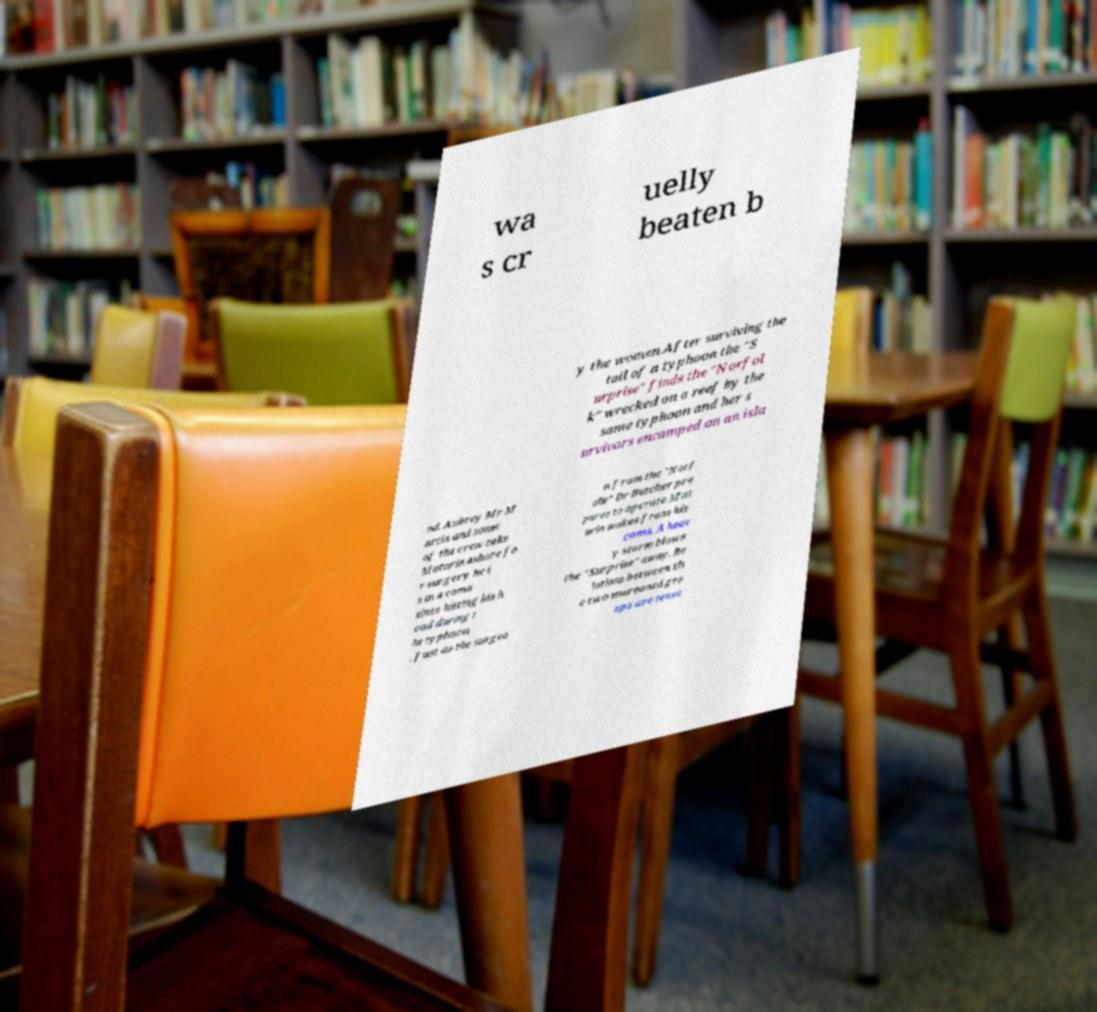What messages or text are displayed in this image? I need them in a readable, typed format. wa s cr uelly beaten b y the women.After surviving the tail of a typhoon the "S urprise" finds the "Norfol k" wrecked on a reef by the same typhoon and her s urvivors encamped on an isla nd. Aubrey Mr M artin and some of the crew take Maturin ashore fo r surgery he i s in a coma since hitting his h ead during t he typhoon . Just as the surgeo n from the "Norf olk" Dr Butcher pre pares to operate Mat urin wakes from his coma. A heav y storm blows the "Surprise" away. Re lations between th e two marooned gro ups are tense 